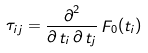Convert formula to latex. <formula><loc_0><loc_0><loc_500><loc_500>\mathop \tau \nolimits _ { i j } = \frac { \mathop \partial \nolimits ^ { 2 } } { \partial \mathop t \nolimits _ { i } \partial \mathop t \nolimits _ { j } } \mathop F \nolimits _ { 0 } ( \mathop t \nolimits _ { i } )</formula> 